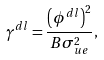Convert formula to latex. <formula><loc_0><loc_0><loc_500><loc_500>\gamma ^ { d l } = \frac { \left ( \phi ^ { d l } \right ) ^ { 2 } } { B \sigma ^ { 2 } _ { u e } } ,</formula> 